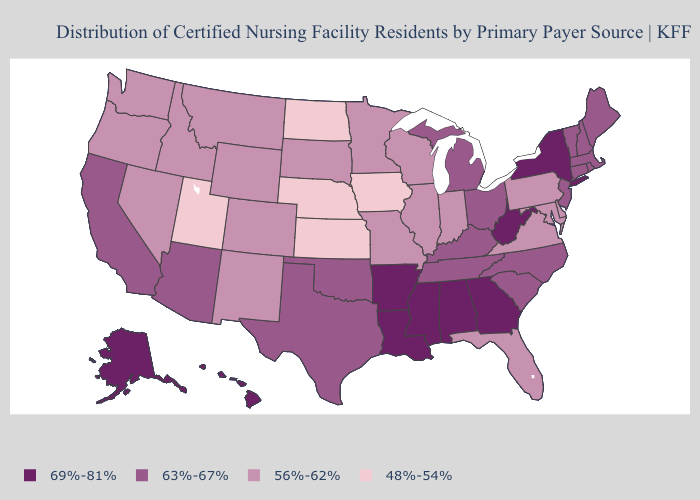Does Wyoming have the lowest value in the USA?
Keep it brief. No. What is the highest value in the South ?
Concise answer only. 69%-81%. Name the states that have a value in the range 69%-81%?
Give a very brief answer. Alabama, Alaska, Arkansas, Georgia, Hawaii, Louisiana, Mississippi, New York, West Virginia. Among the states that border Maryland , which have the lowest value?
Answer briefly. Delaware, Pennsylvania, Virginia. Is the legend a continuous bar?
Keep it brief. No. Does Indiana have a lower value than Idaho?
Be succinct. No. Name the states that have a value in the range 56%-62%?
Answer briefly. Colorado, Delaware, Florida, Idaho, Illinois, Indiana, Maryland, Minnesota, Missouri, Montana, Nevada, New Mexico, Oregon, Pennsylvania, South Dakota, Virginia, Washington, Wisconsin, Wyoming. Name the states that have a value in the range 63%-67%?
Be succinct. Arizona, California, Connecticut, Kentucky, Maine, Massachusetts, Michigan, New Hampshire, New Jersey, North Carolina, Ohio, Oklahoma, Rhode Island, South Carolina, Tennessee, Texas, Vermont. Which states hav the highest value in the West?
Short answer required. Alaska, Hawaii. Does the map have missing data?
Concise answer only. No. Among the states that border North Dakota , which have the highest value?
Be succinct. Minnesota, Montana, South Dakota. Does Massachusetts have a higher value than Vermont?
Keep it brief. No. Which states have the highest value in the USA?
Short answer required. Alabama, Alaska, Arkansas, Georgia, Hawaii, Louisiana, Mississippi, New York, West Virginia. Which states have the lowest value in the MidWest?
Be succinct. Iowa, Kansas, Nebraska, North Dakota. Name the states that have a value in the range 56%-62%?
Concise answer only. Colorado, Delaware, Florida, Idaho, Illinois, Indiana, Maryland, Minnesota, Missouri, Montana, Nevada, New Mexico, Oregon, Pennsylvania, South Dakota, Virginia, Washington, Wisconsin, Wyoming. 